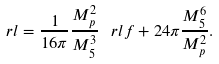<formula> <loc_0><loc_0><loc_500><loc_500>\ r l = \frac { 1 } { 1 6 \pi } \frac { M _ { p } ^ { 2 } } { M ^ { 3 } _ { 5 } } \, \ r l f + 2 4 \pi \frac { M ^ { 6 } _ { 5 } } { M ^ { 2 } _ { p } } .</formula> 